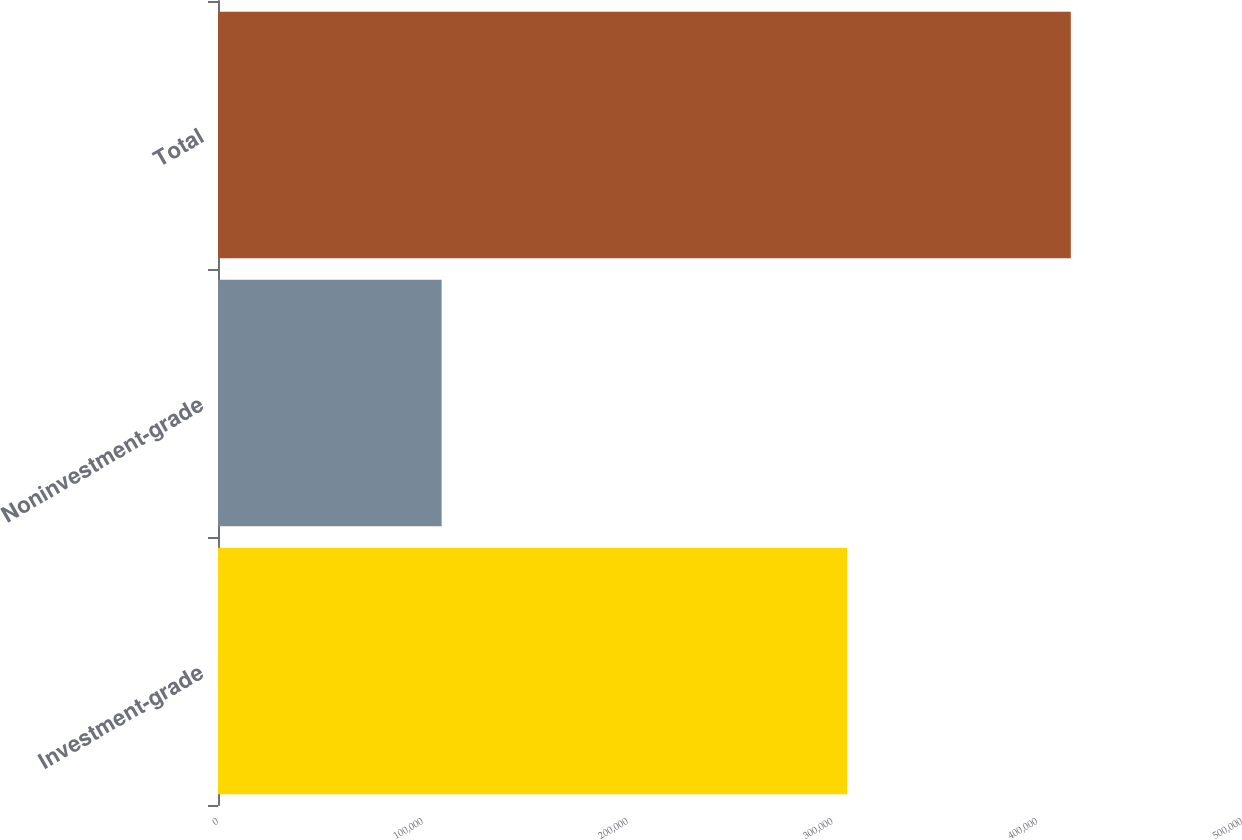Convert chart. <chart><loc_0><loc_0><loc_500><loc_500><bar_chart><fcel>Investment-grade<fcel>Noninvestment-grade<fcel>Total<nl><fcel>307211<fcel>109195<fcel>416406<nl></chart> 